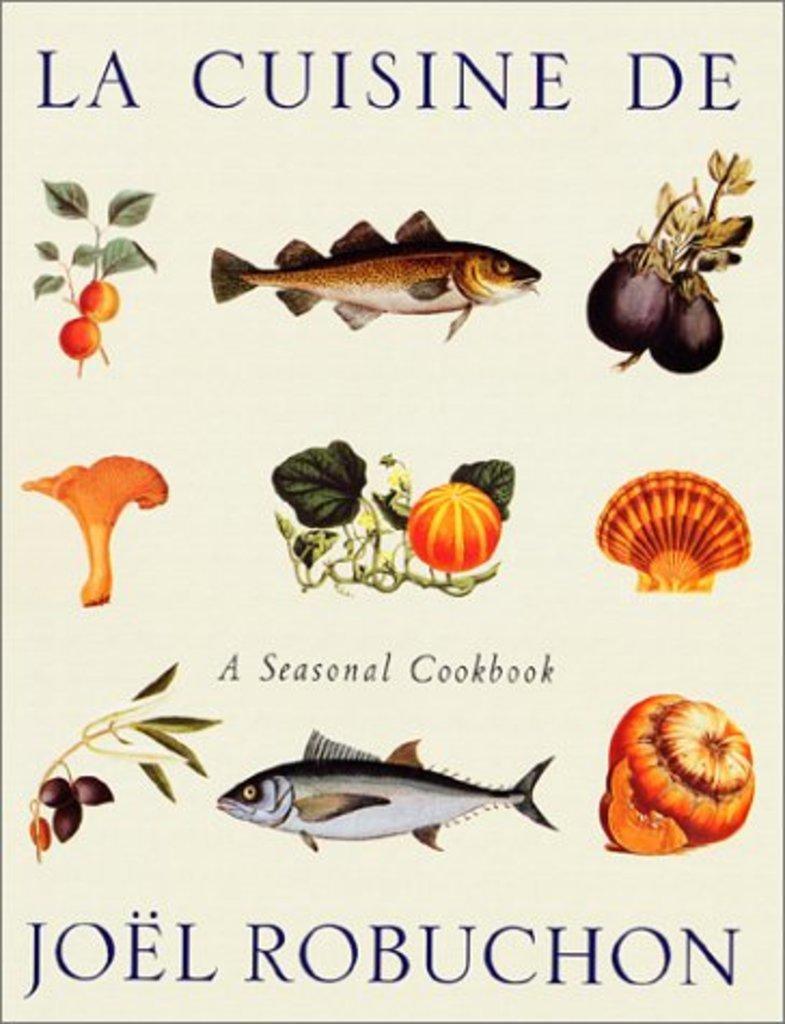What types of food items are depicted in the images? The image contains pictures of fish, vegetables, mushrooms, and fruits. Can you describe the different food groups represented in the image? The image includes pictures of seafood, produce, fungi, and produce. Is there any text present in the image? Yes, there is text written on the paper in the image. What type of bag is being used to carry the baby in the image? There is no baby or bag present in the image; it contains pictures of food items and text on paper. 